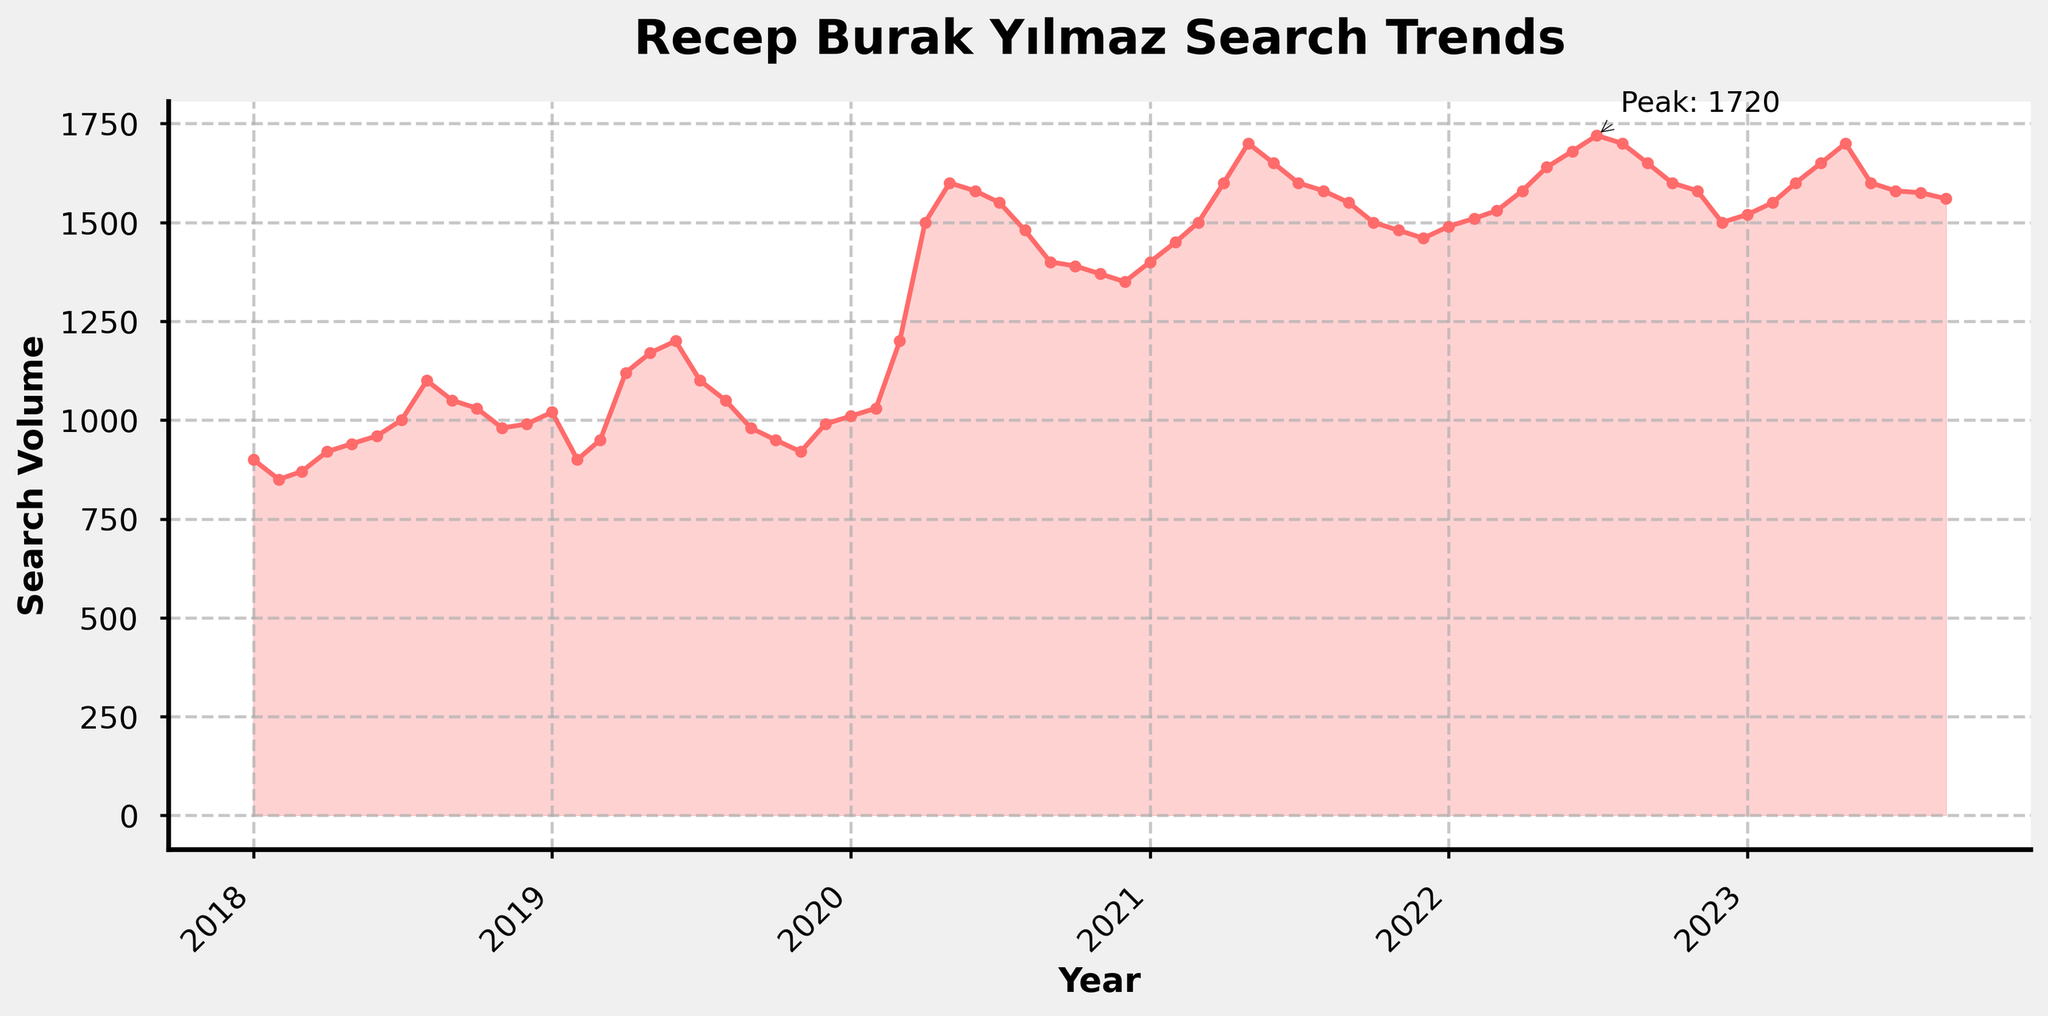What is the peak search volume observed in the plot? The highest search volume corresponds to the maximum data point on the plot. According to the annotation, the peak search volume is 1700.
Answer: 1700 When did the peak search volume occur for Recep Burak Yılmaz? The annotation indicates the peak search volume, and the title next to the peak value shows the month and year it occurred, which is in May 2022.
Answer: May 2022 Describe the trend of search volumes from January 2020 to December 2020. Observing the plot from January 2020 to December 2020, there's a noticeable increase in search volumes, reaching a peak around April and May, slowly decreasing towards the end of the year.
Answer: Increasing, then decreasing How did the search volumes change from 2021 to the beginning of 2023? Search volumes generally increased from 2021, reaching higher levels in 2022 with some fluctuations, then leveling off around the beginning of 2023.
Answer: Increased, then leveled off Which year showed the most significant rise in search volumes? By comparing the slope and increase in the search volumes year-by-year, 2020 shows a sharp rise, starting around 1010 to reaching about 1600 by mid-2020.
Answer: 2020 Calculate the average search volume for the year 2019. The 2019 search volumes are January: 1020, February: 900, March: 950, April: 1120, May: 1170, June: 1200, July: 1100, August: 1050, September: 980, October: 950, November: 920, December: 990. Summing these (12250) and dividing by 12 gives an average of 1020.83.
Answer: 1020.83 Compare the search volumes in July 2020, July 2021, July 2022. Which month had the highest volume among them? In July 2020, the volume was 1550, in July 2021 it was 1600, and in July 2022 it was 1720. Comparing these, July 2022 had the highest search volume.
Answer: July 2022 Identify the month and year when the search volume first reached 1500. By tracking the search volume on the plot, we notice that it first hits 1500 in April 2020.
Answer: April 2020 What is the general trend of search volumes from 2018 to 2023? Observing the overall plot indicates that there is a general upward trend in the search volumes for Recep Burak Yılmaz from 2018 to 2023.
Answer: Upward trend 